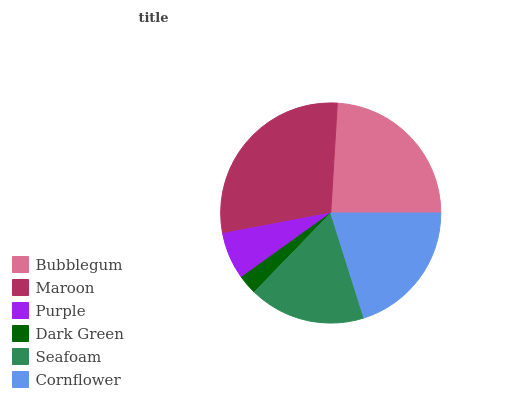Is Dark Green the minimum?
Answer yes or no. Yes. Is Maroon the maximum?
Answer yes or no. Yes. Is Purple the minimum?
Answer yes or no. No. Is Purple the maximum?
Answer yes or no. No. Is Maroon greater than Purple?
Answer yes or no. Yes. Is Purple less than Maroon?
Answer yes or no. Yes. Is Purple greater than Maroon?
Answer yes or no. No. Is Maroon less than Purple?
Answer yes or no. No. Is Cornflower the high median?
Answer yes or no. Yes. Is Seafoam the low median?
Answer yes or no. Yes. Is Dark Green the high median?
Answer yes or no. No. Is Dark Green the low median?
Answer yes or no. No. 